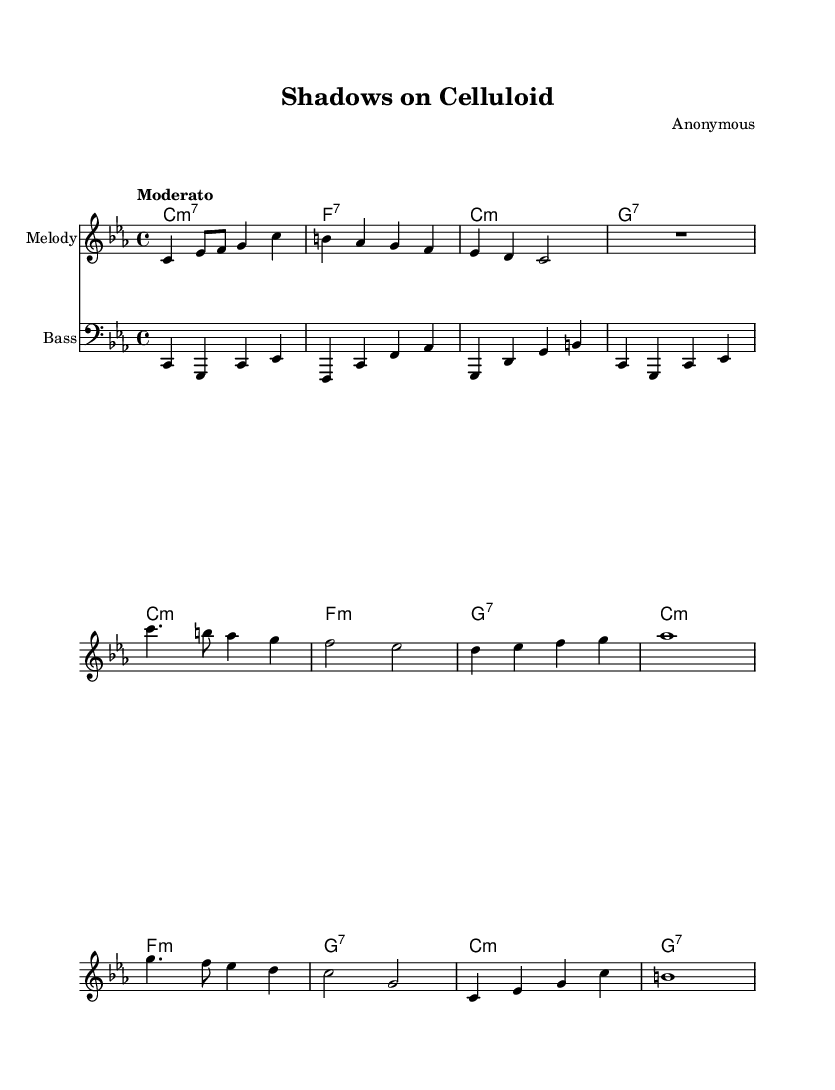What is the key signature of this music? The key signature indicated in the music is C minor, which has three flats (B♭, E♭, A♭).
Answer: C minor What is the time signature of this music? The time signature seen in the music is 4/4, which indicates four beats per measure.
Answer: 4/4 What is the tempo marking of this piece? The tempo marking "Moderato" is indicated above the staff, suggesting a moderate speed for the performance.
Answer: Moderato What type of chord is featured in the harmonies section? The harmonies contain seventh chords, as indicated by the notation "m7" and "7," which signify minor and dominant seventh chords.
Answer: Seventh chords How many measures are in the Intro section? By counting each segment of the provided measures in the score, we identify that there are four measures in the Intro section.
Answer: 4 measures What is the last note in the melody? The last note in the melody is a whole note (b) marked in the final measure, which indicates it is held for the entire measure.
Answer: b Which clef is used for the bass part? The bass part is written in the bass clef, indicated by the clef symbol at the start of the staff.
Answer: Bass clef 